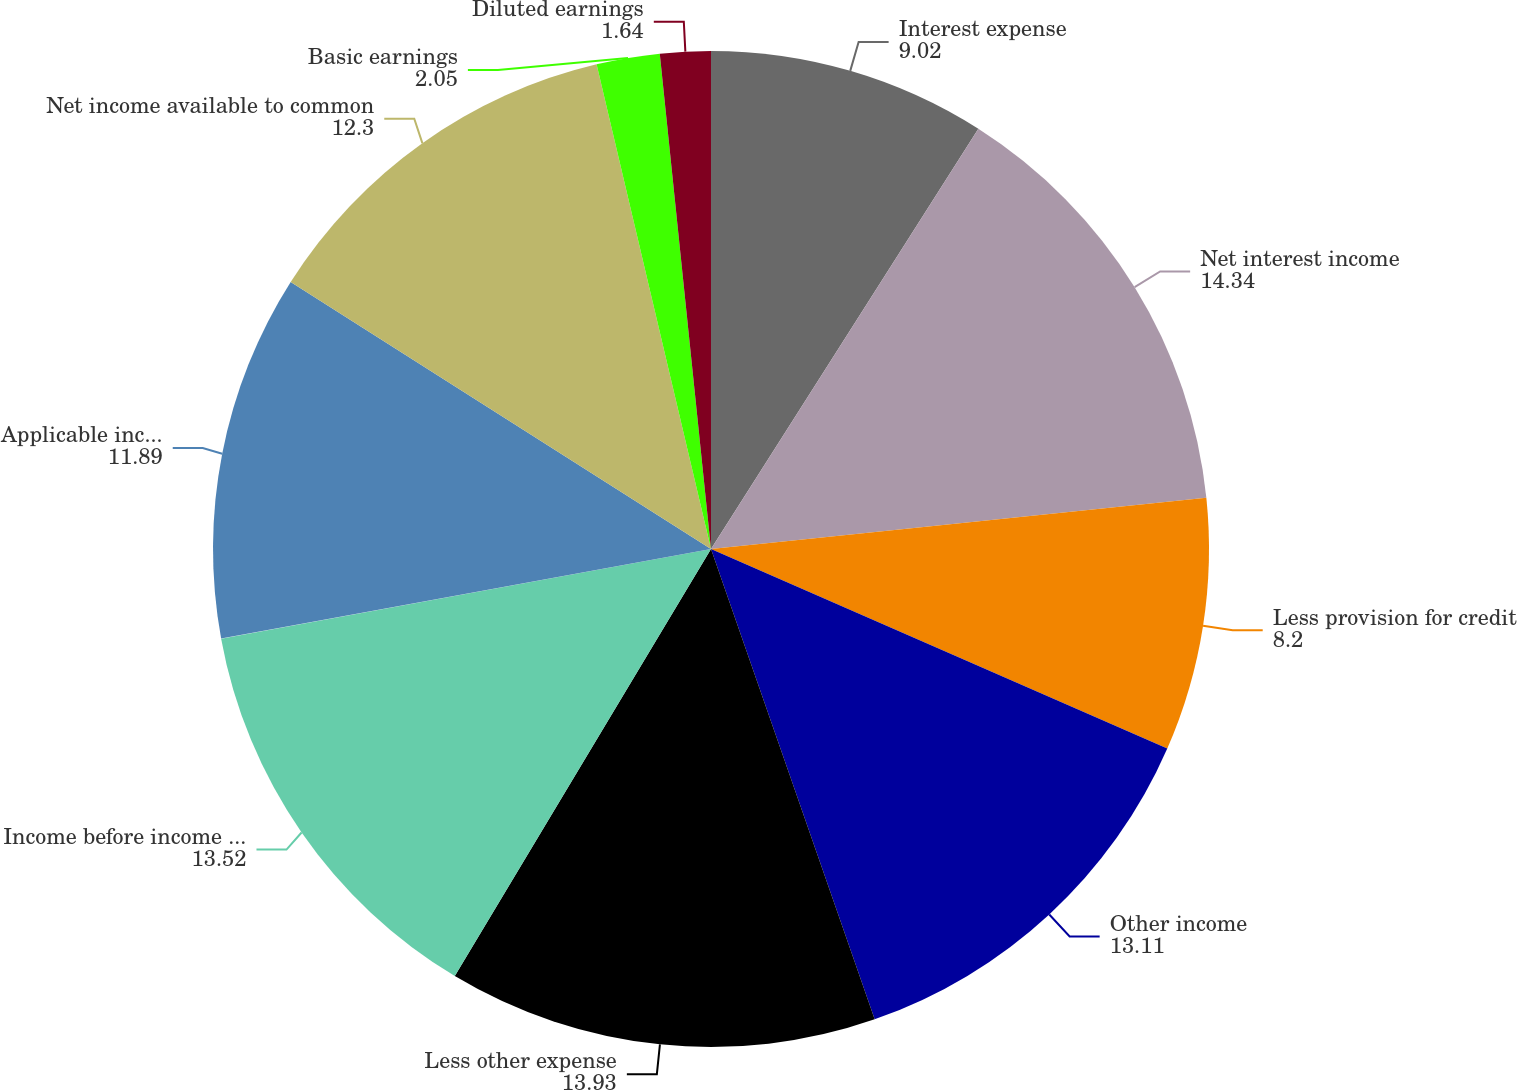Convert chart. <chart><loc_0><loc_0><loc_500><loc_500><pie_chart><fcel>Interest expense<fcel>Net interest income<fcel>Less provision for credit<fcel>Other income<fcel>Less other expense<fcel>Income before income taxes<fcel>Applicable income taxes<fcel>Net income available to common<fcel>Basic earnings<fcel>Diluted earnings<nl><fcel>9.02%<fcel>14.34%<fcel>8.2%<fcel>13.11%<fcel>13.93%<fcel>13.52%<fcel>11.89%<fcel>12.3%<fcel>2.05%<fcel>1.64%<nl></chart> 